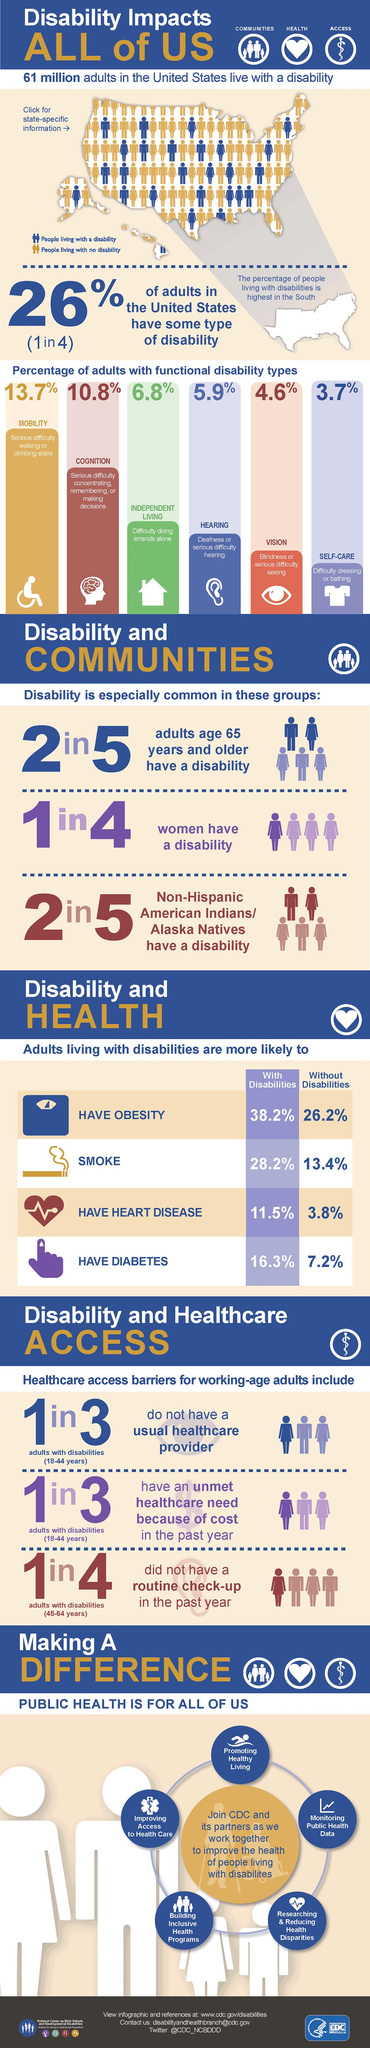Point out several critical features in this image. According to recent statistics, approximately 13.7% of adults in the United States have mobility disabilities. According to a recent study, 10.8% of adults have cognitive disabilities. 